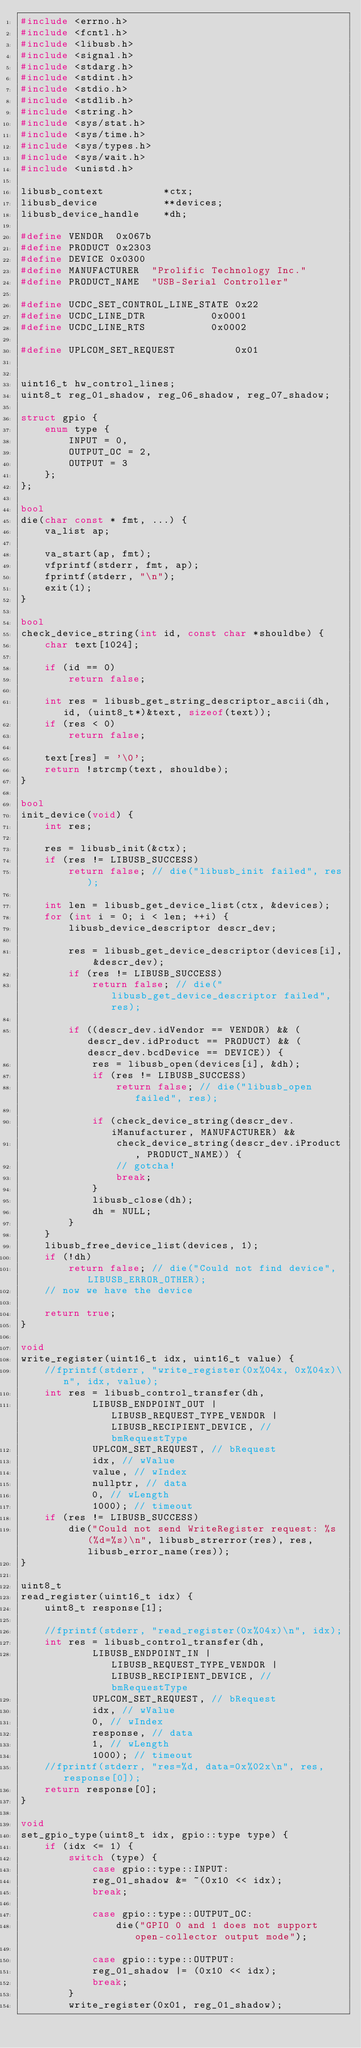Convert code to text. <code><loc_0><loc_0><loc_500><loc_500><_C++_>#include <errno.h>
#include <fcntl.h>
#include <libusb.h>
#include <signal.h>
#include <stdarg.h>
#include <stdint.h>
#include <stdio.h>
#include <stdlib.h>
#include <string.h>
#include <sys/stat.h>
#include <sys/time.h>
#include <sys/types.h>
#include <sys/wait.h>
#include <unistd.h>

libusb_context          *ctx;
libusb_device           **devices;
libusb_device_handle    *dh;

#define VENDOR  0x067b
#define PRODUCT 0x2303
#define DEVICE 0x0300
#define MANUFACTURER  "Prolific Technology Inc."
#define PRODUCT_NAME  "USB-Serial Controller"

#define UCDC_SET_CONTROL_LINE_STATE 0x22
#define UCDC_LINE_DTR           0x0001
#define UCDC_LINE_RTS           0x0002

#define UPLCOM_SET_REQUEST          0x01


uint16_t hw_control_lines;
uint8_t reg_01_shadow, reg_06_shadow, reg_07_shadow;

struct gpio {
    enum type {
        INPUT = 0,
        OUTPUT_OC = 2,
        OUTPUT = 3
    };
};

bool
die(char const * fmt, ...) {
    va_list ap;

    va_start(ap, fmt);
    vfprintf(stderr, fmt, ap);
    fprintf(stderr, "\n");
    exit(1);
}

bool
check_device_string(int id, const char *shouldbe) {
    char text[1024];

    if (id == 0)
        return false;

    int res = libusb_get_string_descriptor_ascii(dh, id, (uint8_t*)&text, sizeof(text));
    if (res < 0)
        return false;

    text[res] = '\0';
    return !strcmp(text, shouldbe);
}

bool
init_device(void) {
    int res;

    res = libusb_init(&ctx);
    if (res != LIBUSB_SUCCESS)
        return false; // die("libusb_init failed", res);

    int len = libusb_get_device_list(ctx, &devices);
    for (int i = 0; i < len; ++i) {
        libusb_device_descriptor descr_dev;

        res = libusb_get_device_descriptor(devices[i], &descr_dev);
        if (res != LIBUSB_SUCCESS)
            return false; // die("libusb_get_device_descriptor failed", res);

        if ((descr_dev.idVendor == VENDOR) && (descr_dev.idProduct == PRODUCT) && (descr_dev.bcdDevice == DEVICE)) {
            res = libusb_open(devices[i], &dh);
            if (res != LIBUSB_SUCCESS)
                return false; // die("libusb_open failed", res);

            if (check_device_string(descr_dev.iManufacturer, MANUFACTURER) &&
                check_device_string(descr_dev.iProduct, PRODUCT_NAME)) {
                // gotcha!
                break;
            }
            libusb_close(dh);
            dh = NULL;
        }
    }
    libusb_free_device_list(devices, 1);
    if (!dh)
        return false; // die("Could not find device", LIBUSB_ERROR_OTHER);
    // now we have the device

    return true;
}

void
write_register(uint16_t idx, uint16_t value) {
    //fprintf(stderr, "write_register(0x%04x, 0x%04x)\n", idx, value);
    int res = libusb_control_transfer(dh,
            LIBUSB_ENDPOINT_OUT | LIBUSB_REQUEST_TYPE_VENDOR | LIBUSB_RECIPIENT_DEVICE, // bmRequestType
            UPLCOM_SET_REQUEST, // bRequest
            idx, // wValue
            value, // wIndex
            nullptr, // data
            0, // wLength
            1000); // timeout
    if (res != LIBUSB_SUCCESS)
        die("Could not send WriteRegister request: %s (%d=%s)\n", libusb_strerror(res), res, libusb_error_name(res));
}

uint8_t
read_register(uint16_t idx) {
    uint8_t response[1];

    //fprintf(stderr, "read_register(0x%04x)\n", idx);
    int res = libusb_control_transfer(dh,
            LIBUSB_ENDPOINT_IN | LIBUSB_REQUEST_TYPE_VENDOR | LIBUSB_RECIPIENT_DEVICE, // bmRequestType
            UPLCOM_SET_REQUEST, // bRequest
            idx, // wValue
            0, // wIndex
            response, // data
            1, // wLength
            1000); // timeout
    //fprintf(stderr, "res=%d, data=0x%02x\n", res, response[0]);
    return response[0];
}

void
set_gpio_type(uint8_t idx, gpio::type type) {
    if (idx <= 1) {
        switch (type) {
            case gpio::type::INPUT:
            reg_01_shadow &= ~(0x10 << idx);
            break;

            case gpio::type::OUTPUT_OC:
                die("GPIO 0 and 1 does not support open-collector output mode");

            case gpio::type::OUTPUT:
            reg_01_shadow |= (0x10 << idx);
            break;
        }
        write_register(0x01, reg_01_shadow);</code> 